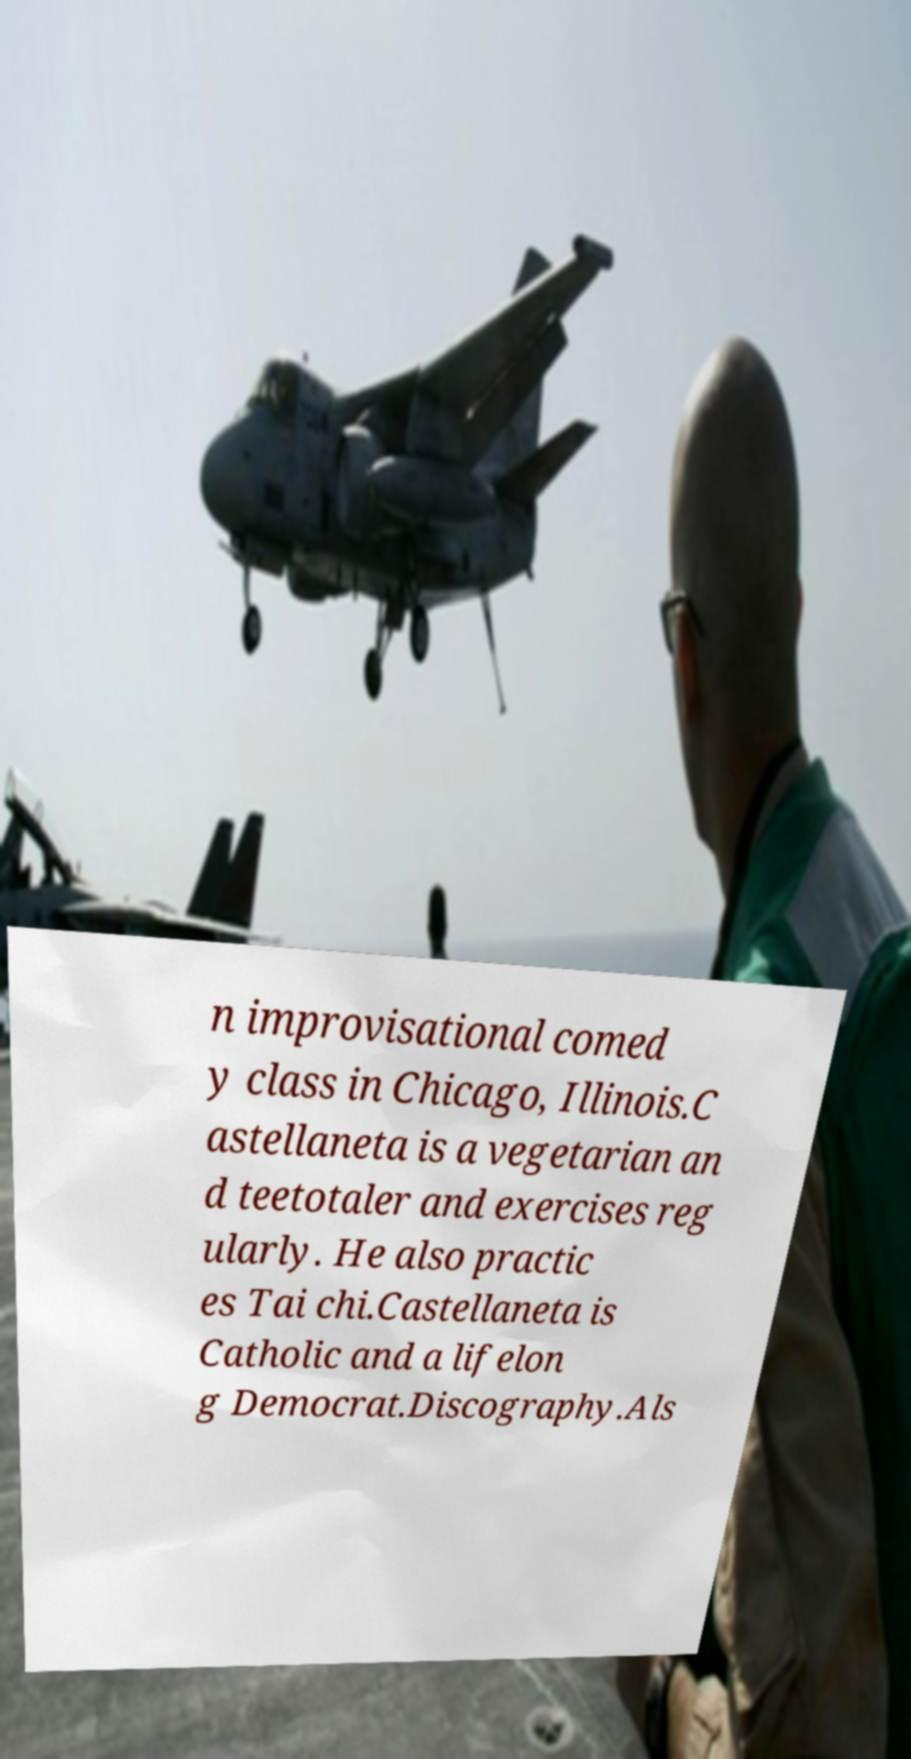Please identify and transcribe the text found in this image. n improvisational comed y class in Chicago, Illinois.C astellaneta is a vegetarian an d teetotaler and exercises reg ularly. He also practic es Tai chi.Castellaneta is Catholic and a lifelon g Democrat.Discography.Als 